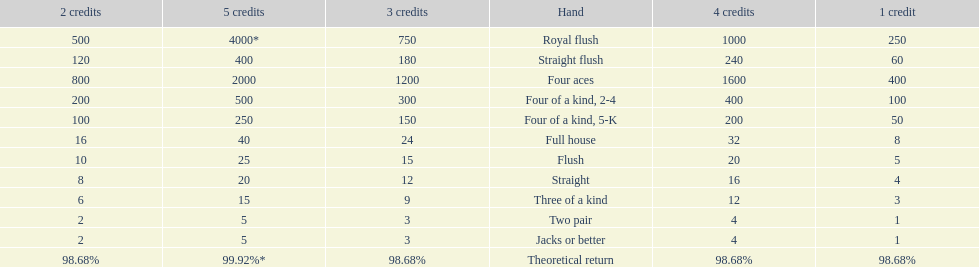Give me the full table as a dictionary. {'header': ['2 credits', '5 credits', '3 credits', 'Hand', '4 credits', '1 credit'], 'rows': [['500', '4000*', '750', 'Royal flush', '1000', '250'], ['120', '400', '180', 'Straight flush', '240', '60'], ['800', '2000', '1200', 'Four aces', '1600', '400'], ['200', '500', '300', 'Four of a kind, 2-4', '400', '100'], ['100', '250', '150', 'Four of a kind, 5-K', '200', '50'], ['16', '40', '24', 'Full house', '32', '8'], ['10', '25', '15', 'Flush', '20', '5'], ['8', '20', '12', 'Straight', '16', '4'], ['6', '15', '9', 'Three of a kind', '12', '3'], ['2', '5', '3', 'Two pair', '4', '1'], ['2', '5', '3', 'Jacks or better', '4', '1'], ['98.68%', '99.92%*', '98.68%', 'Theoretical return', '98.68%', '98.68%']]} After winning on four credits with a full house, what is your payout? 32. 